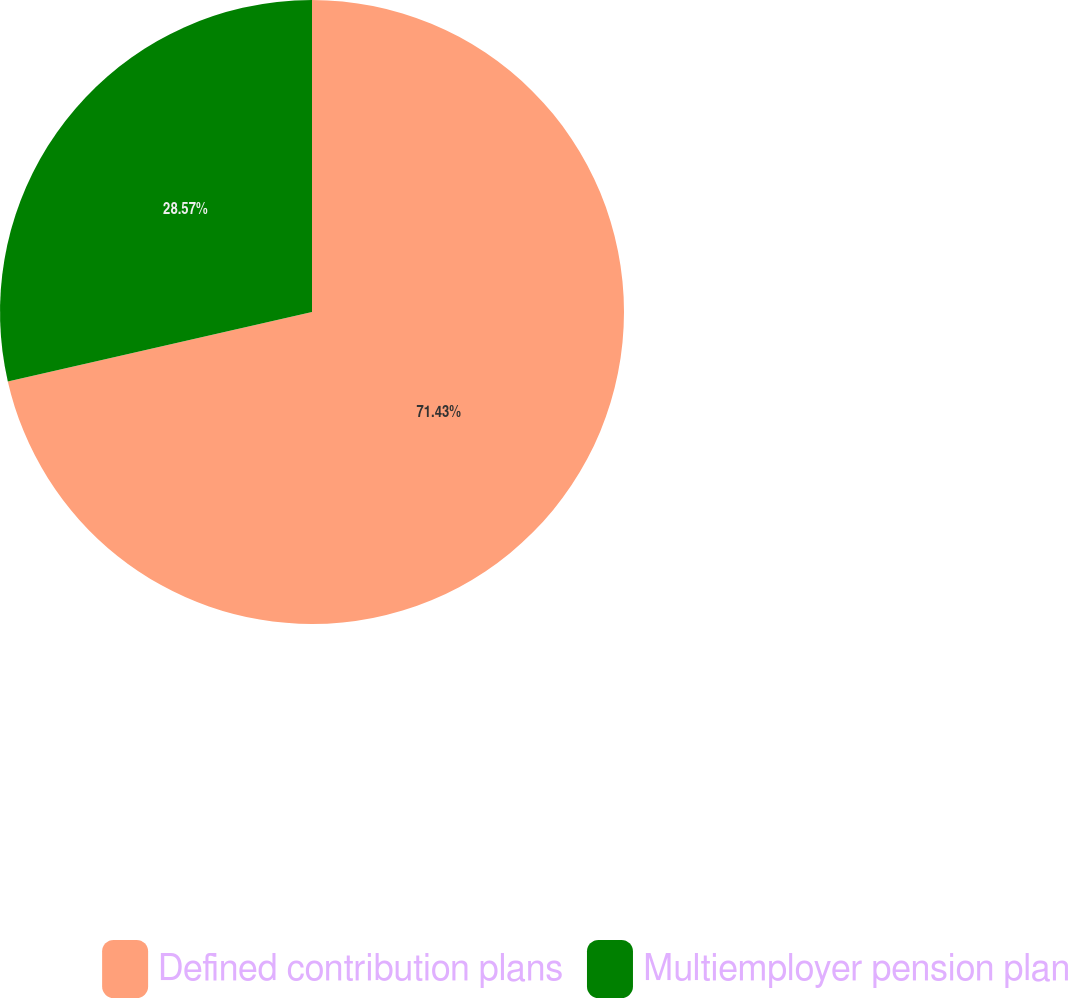<chart> <loc_0><loc_0><loc_500><loc_500><pie_chart><fcel>Defined contribution plans<fcel>Multiemployer pension plan<nl><fcel>71.43%<fcel>28.57%<nl></chart> 